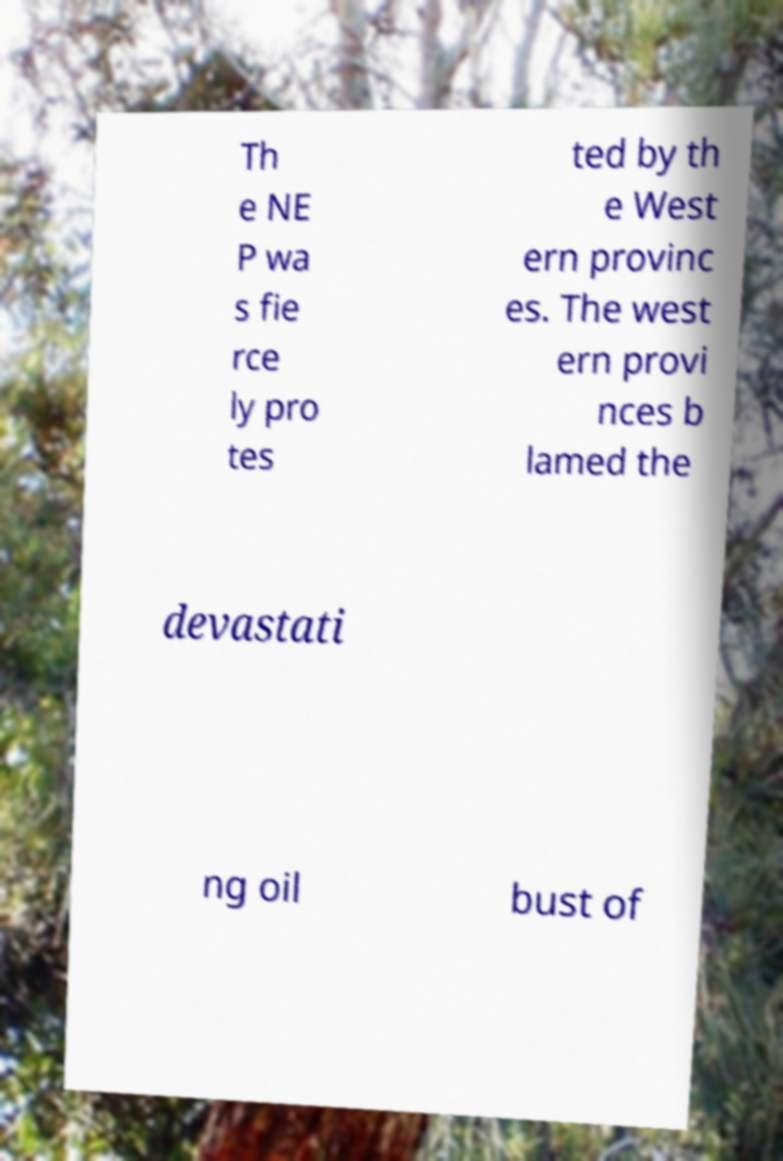Please identify and transcribe the text found in this image. Th e NE P wa s fie rce ly pro tes ted by th e West ern provinc es. The west ern provi nces b lamed the devastati ng oil bust of 